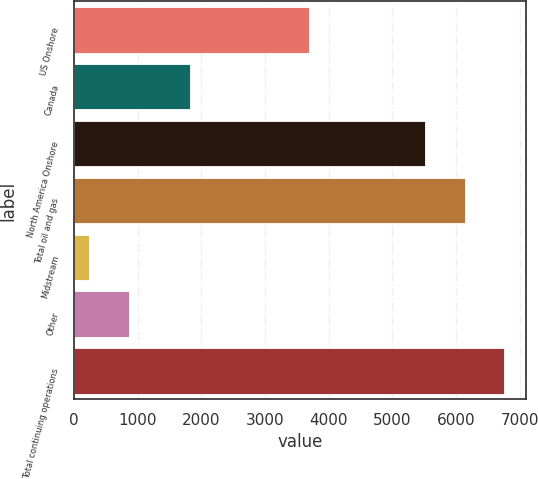<chart> <loc_0><loc_0><loc_500><loc_500><bar_chart><fcel>US Onshore<fcel>Canada<fcel>North America Onshore<fcel>Total oil and gas<fcel>Midstream<fcel>Other<fcel>Total continuing operations<nl><fcel>3689<fcel>1826<fcel>5515<fcel>6139<fcel>236<fcel>860<fcel>6763<nl></chart> 